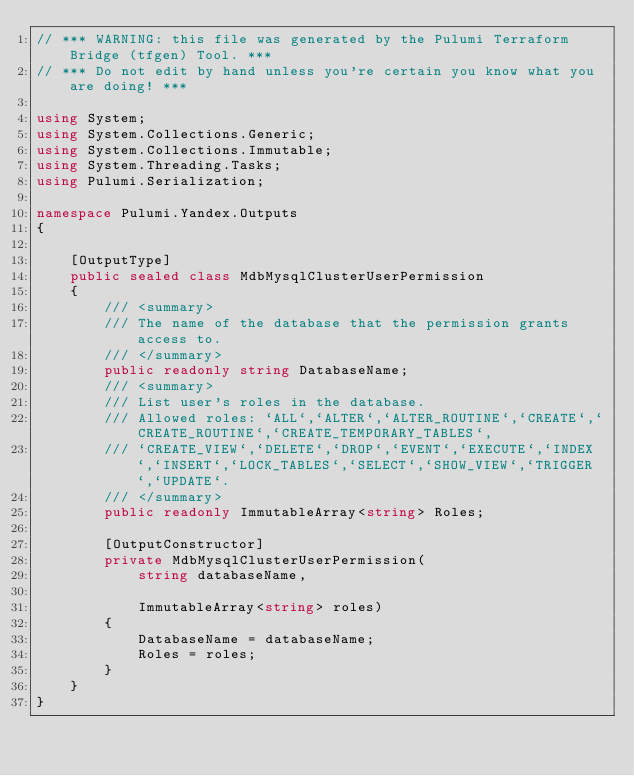Convert code to text. <code><loc_0><loc_0><loc_500><loc_500><_C#_>// *** WARNING: this file was generated by the Pulumi Terraform Bridge (tfgen) Tool. ***
// *** Do not edit by hand unless you're certain you know what you are doing! ***

using System;
using System.Collections.Generic;
using System.Collections.Immutable;
using System.Threading.Tasks;
using Pulumi.Serialization;

namespace Pulumi.Yandex.Outputs
{

    [OutputType]
    public sealed class MdbMysqlClusterUserPermission
    {
        /// <summary>
        /// The name of the database that the permission grants access to.
        /// </summary>
        public readonly string DatabaseName;
        /// <summary>
        /// List user's roles in the database.
        /// Allowed roles: `ALL`,`ALTER`,`ALTER_ROUTINE`,`CREATE`,`CREATE_ROUTINE`,`CREATE_TEMPORARY_TABLES`,
        /// `CREATE_VIEW`,`DELETE`,`DROP`,`EVENT`,`EXECUTE`,`INDEX`,`INSERT`,`LOCK_TABLES`,`SELECT`,`SHOW_VIEW`,`TRIGGER`,`UPDATE`.
        /// </summary>
        public readonly ImmutableArray<string> Roles;

        [OutputConstructor]
        private MdbMysqlClusterUserPermission(
            string databaseName,

            ImmutableArray<string> roles)
        {
            DatabaseName = databaseName;
            Roles = roles;
        }
    }
}
</code> 